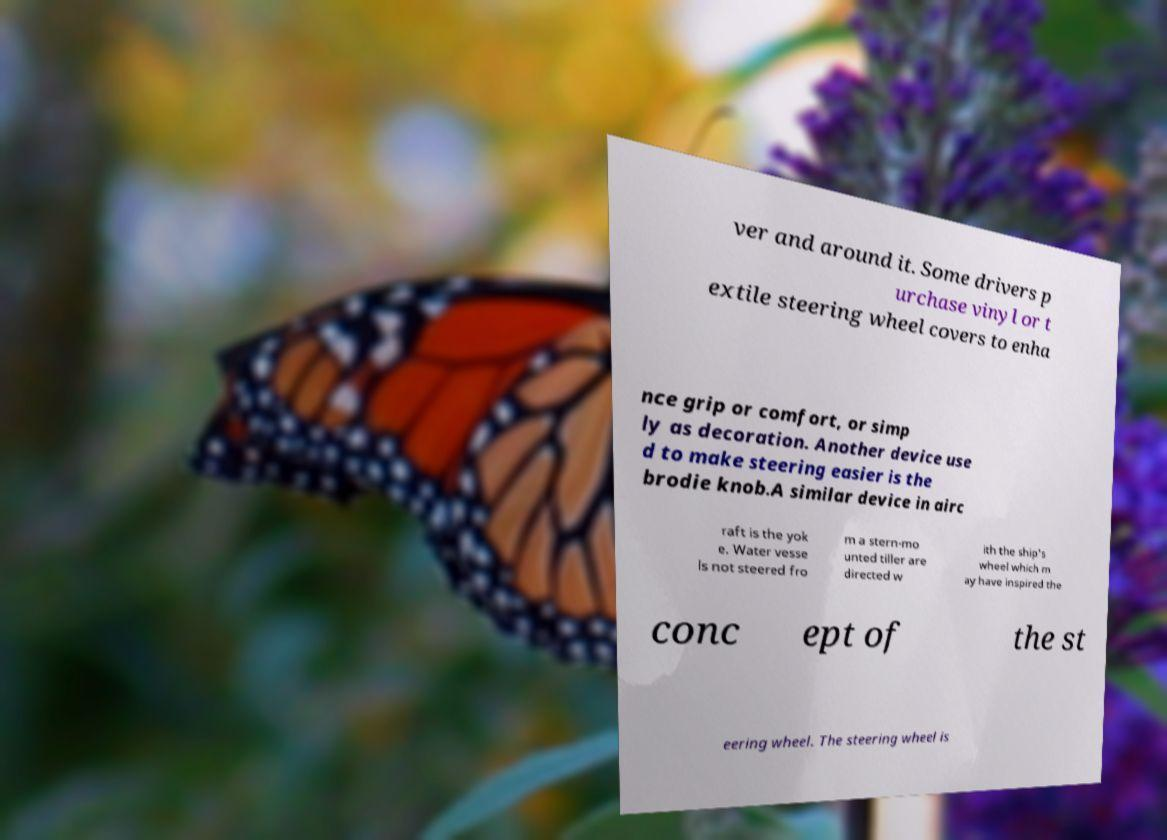Can you accurately transcribe the text from the provided image for me? ver and around it. Some drivers p urchase vinyl or t extile steering wheel covers to enha nce grip or comfort, or simp ly as decoration. Another device use d to make steering easier is the brodie knob.A similar device in airc raft is the yok e. Water vesse ls not steered fro m a stern-mo unted tiller are directed w ith the ship's wheel which m ay have inspired the conc ept of the st eering wheel. The steering wheel is 